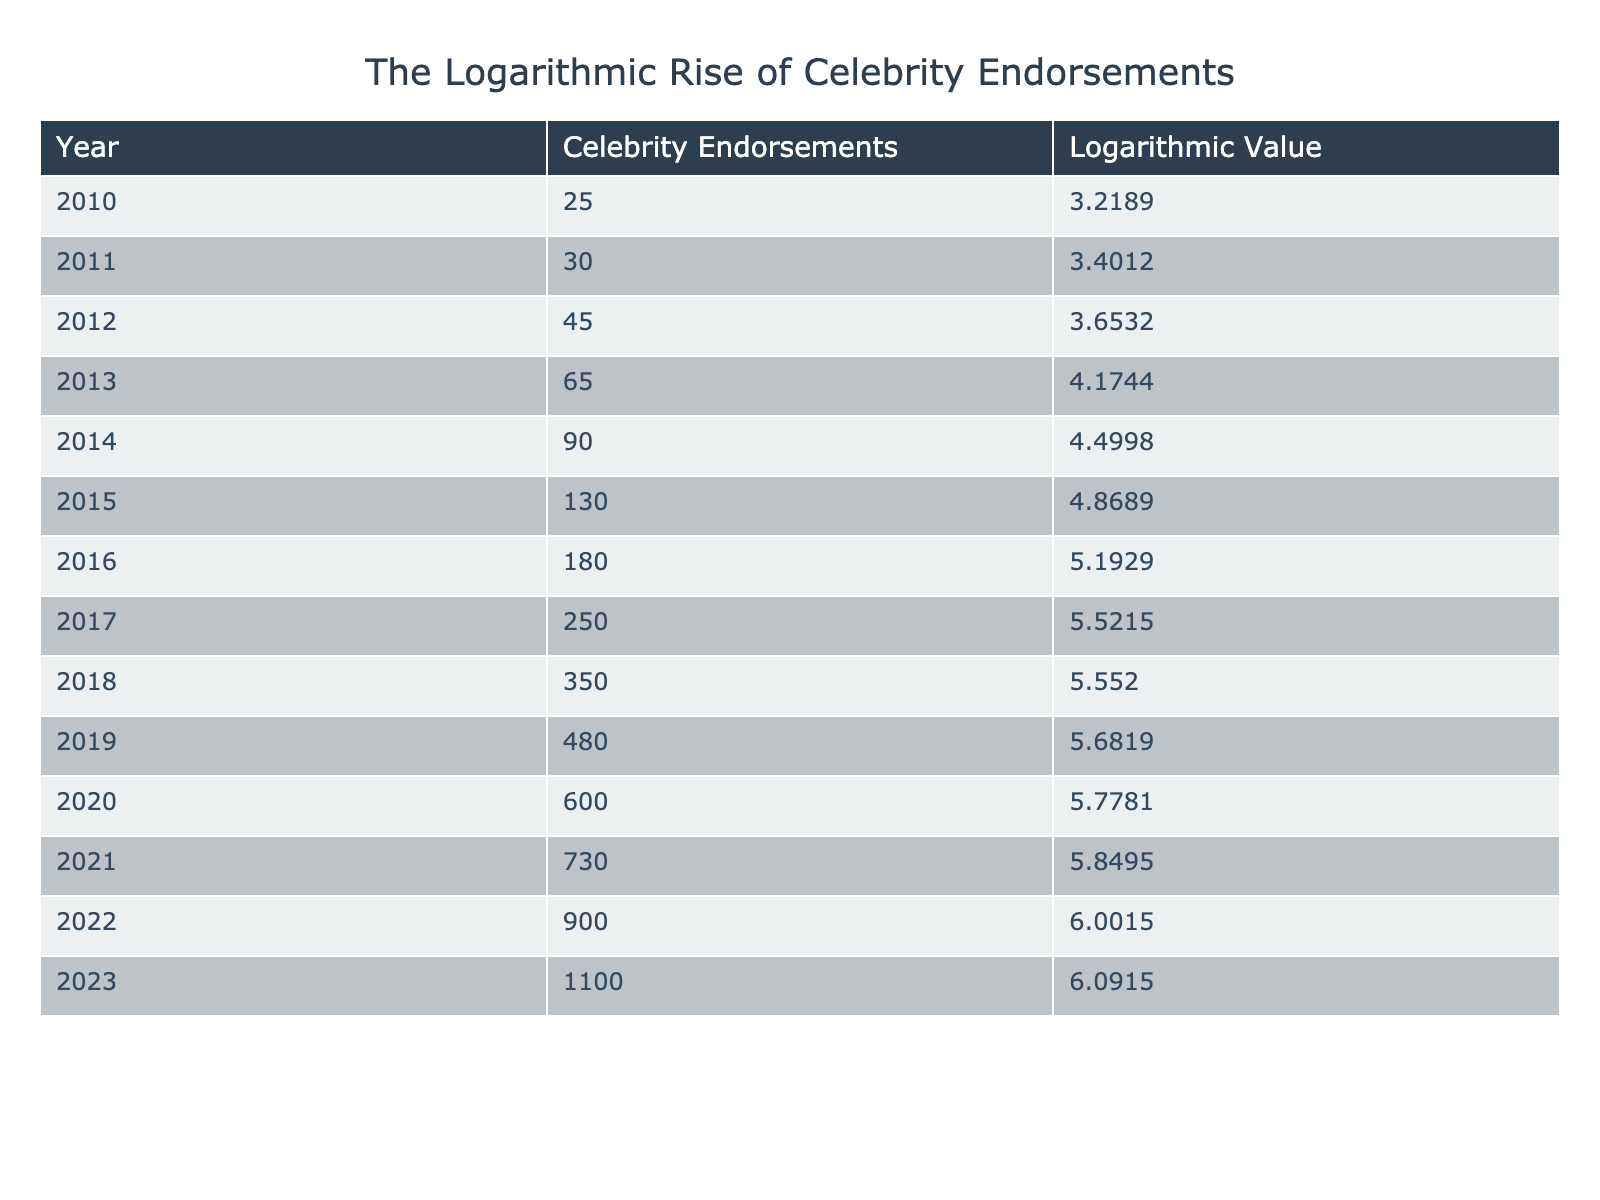What was the year with the highest number of celebrity endorsements? Looking at the "Celebrity Endorsements" column, the highest number listed is 1100, which corresponds to the year 2023.
Answer: 2023 What was the logarithmic value of celebrity endorsements in 2015? Referring to the "Logarithmic Value" column, the value for 2015 is 4.8689.
Answer: 4.8689 What is the difference in the number of celebrity endorsements between 2010 and 2023? The number of endorsements in 2010 is 25 and in 2023 is 1100. The difference is calculated as 1100 - 25 = 1075.
Answer: 1075 What was the average number of celebrity endorsements from 2010 to 2015? To find the average, we sum the endorsements from 2010 (25), 2011 (30), 2012 (45), 2013 (65), 2014 (90), and 2015 (130) to get a total of 385. There are 6 years, so the average is 385/6 = 64.17, rounded to 64.
Answer: 64 Did the number of celebrity endorsements decrease at any point from 2010 to 2023? Reviewing the table, there are no decreases in the number of endorsements from year to year; it consistently increases every year.
Answer: No In which year did the logarithmic value first exceed 5? Looking at the "Logarithmic Value" column, the value first exceeds 5 in the year 2016 (5.1929).
Answer: 2016 How many more endorsements were there in 2020 compared to 2011? The endorsements in 2020 are 600 and in 2011 they are 30. The difference is 600 - 30 = 570 endorsements more in 2020.
Answer: 570 What is the total number of endorsements from 2017 to 2023? Summing the endorsements from 2017 (250), 2018 (350), 2019 (480), 2020 (600), 2021 (730), 2022 (900), and 2023 (1100) gives a total of 3500 endorsements across those years (250 + 350 + 480 + 600 + 730 + 900 + 1100 = 3500).
Answer: 3500 